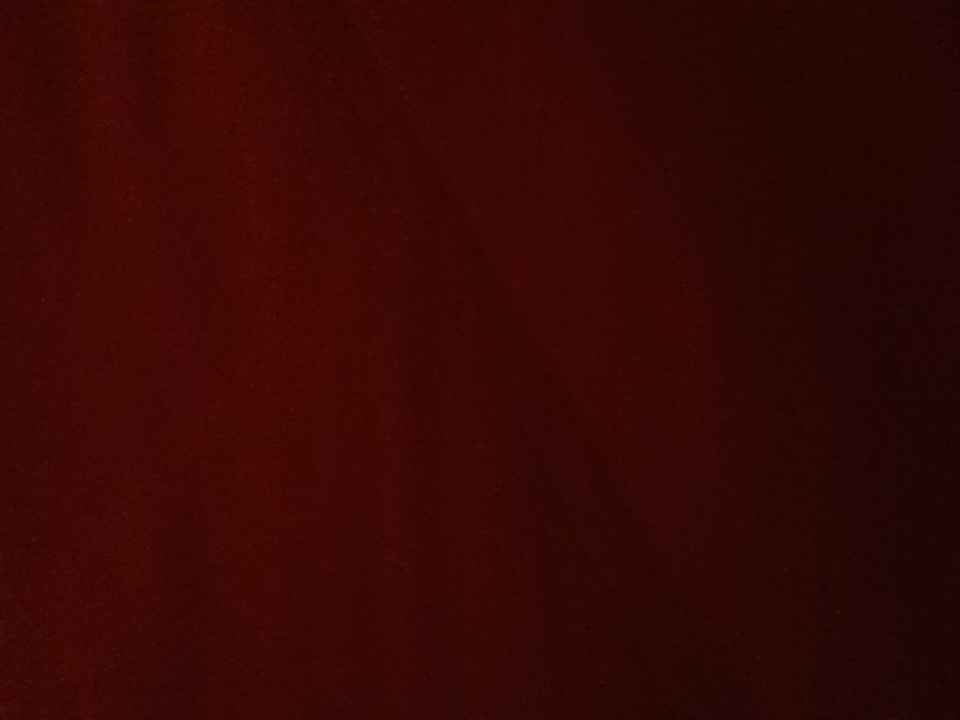Can you describe the texture and possible material this color might belong to? The color in the image, being a deep, rich red, could be associated with luxurious materials such as velvet, satin, or high-quality wool. Its dark and uniform appearance suggests it might belong to an elegant piece of fabric or clothing, perhaps a dress, curtain, or upholstery. Why might someone choose this color for their decor? A deep red color like this can evoke a sense of warmth, luxury, and sophistication. It's a popular choice for those looking to create an elegant and inviting atmosphere in their homes. This color could be used to add a touch of drama to a room, making it feel cozy and rich. It's particularly effective in spaces where you want to induce a sense of intimacy, like a living room or bedroom. 